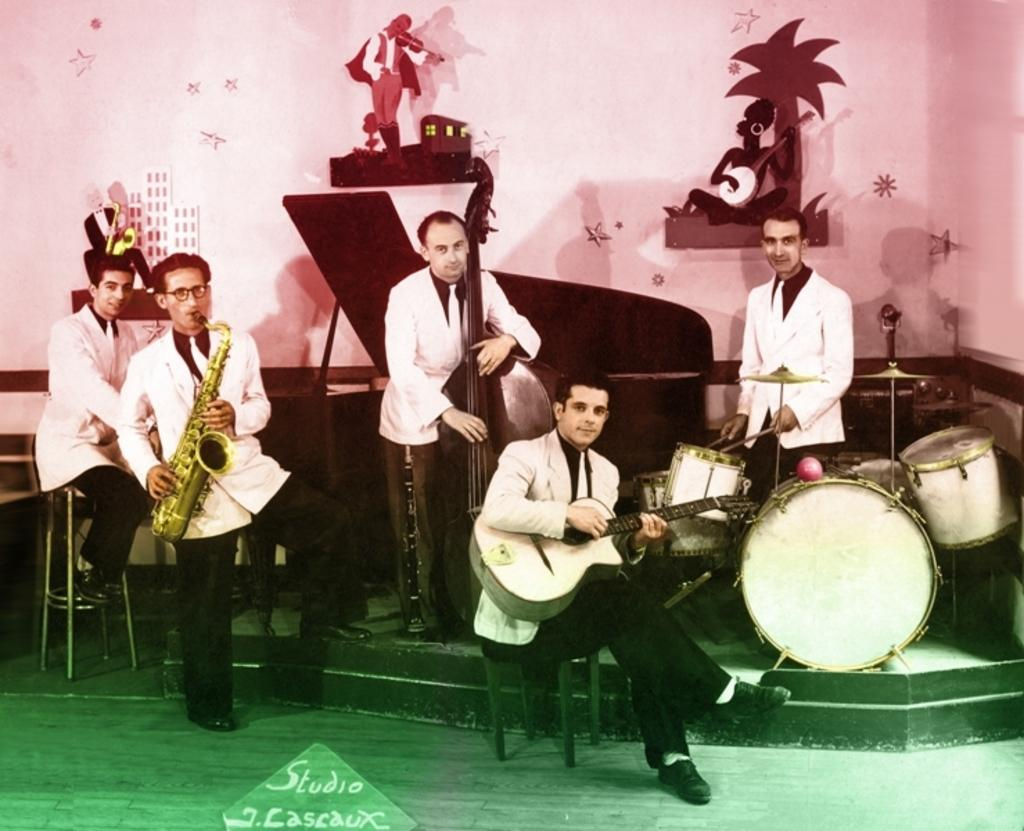How many people are in the image? There are 5 men in the image. What are the men doing in the image? The men are holding musical instruments and posing for the image. What else can be seen in the image besides the men and their instruments? There are wall stickers visible in the image. What type of eggs can be seen in the image? There are no eggs present in the image. How does the image answer the question about the best way to cook pasta? The image does not provide an answer to any question about cooking pasta, as it features 5 men holding musical instruments and posing for the image. 